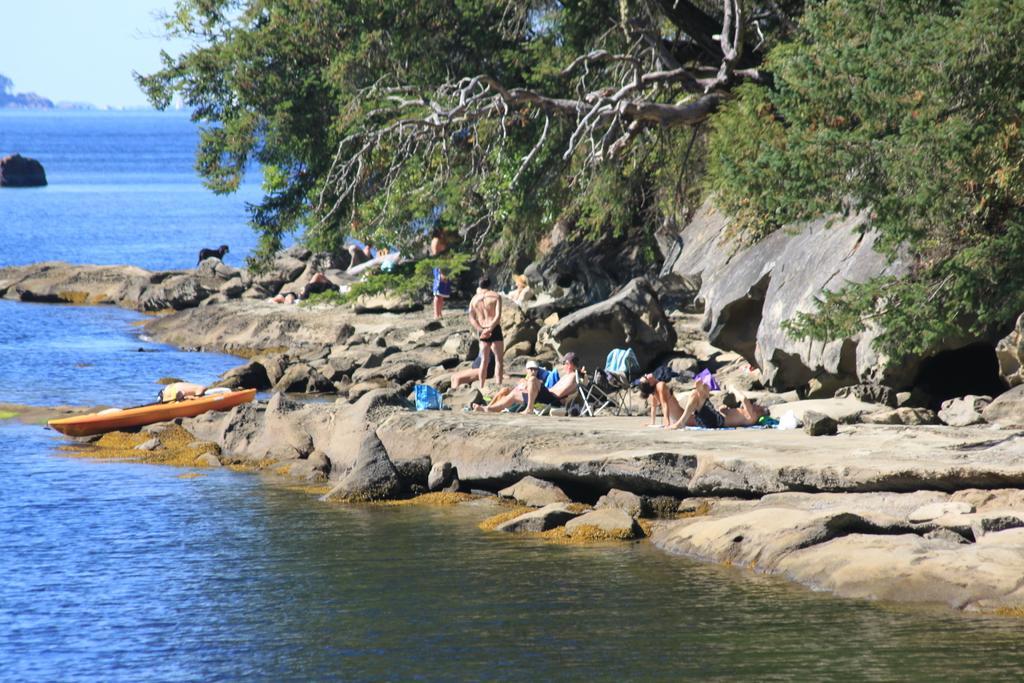Describe this image in one or two sentences. In this picture I can see some persons who are lying on the ground, beside them I can see the chair. Beside the stones I can see the man who is standing near to the water. On the left there is a orange color boat. In the background I can see the ocean. On the right I can see many trees. In the top left I can see the sky. 